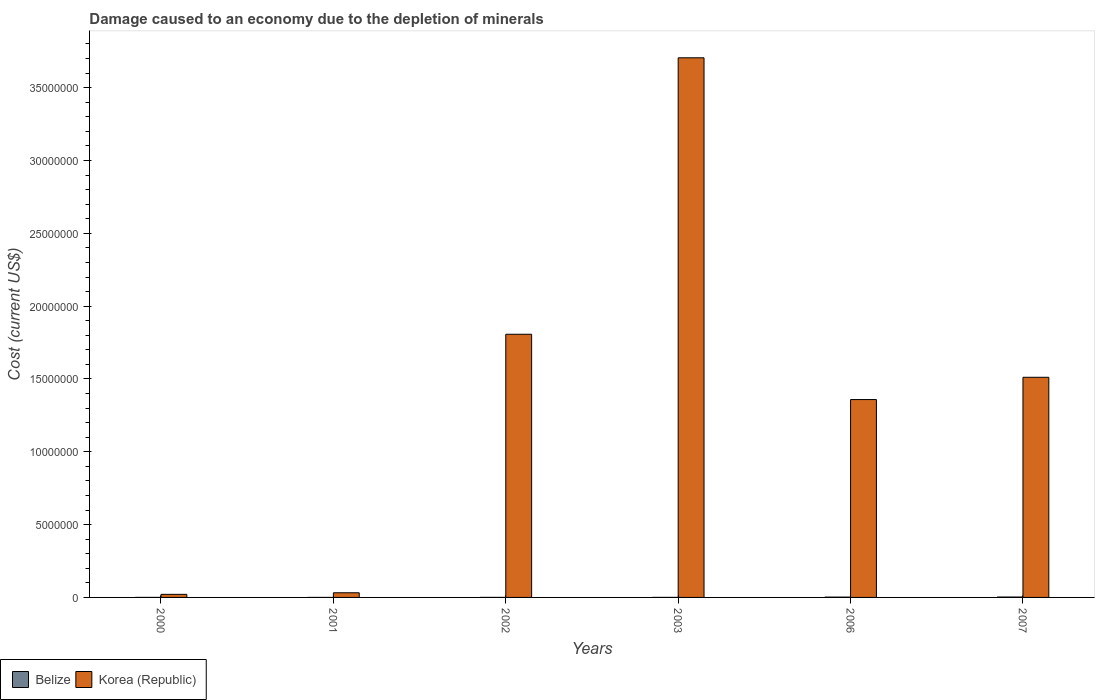How many groups of bars are there?
Make the answer very short. 6. Are the number of bars on each tick of the X-axis equal?
Your answer should be very brief. Yes. How many bars are there on the 3rd tick from the left?
Give a very brief answer. 2. What is the label of the 1st group of bars from the left?
Your answer should be compact. 2000. In how many cases, is the number of bars for a given year not equal to the number of legend labels?
Your answer should be compact. 0. What is the cost of damage caused due to the depletion of minerals in Korea (Republic) in 2002?
Provide a succinct answer. 1.81e+07. Across all years, what is the maximum cost of damage caused due to the depletion of minerals in Korea (Republic)?
Provide a short and direct response. 3.71e+07. Across all years, what is the minimum cost of damage caused due to the depletion of minerals in Belize?
Your response must be concise. 126.73. In which year was the cost of damage caused due to the depletion of minerals in Korea (Republic) maximum?
Offer a terse response. 2003. In which year was the cost of damage caused due to the depletion of minerals in Korea (Republic) minimum?
Your response must be concise. 2000. What is the total cost of damage caused due to the depletion of minerals in Korea (Republic) in the graph?
Provide a succinct answer. 8.44e+07. What is the difference between the cost of damage caused due to the depletion of minerals in Korea (Republic) in 2000 and that in 2002?
Keep it short and to the point. -1.79e+07. What is the difference between the cost of damage caused due to the depletion of minerals in Korea (Republic) in 2000 and the cost of damage caused due to the depletion of minerals in Belize in 2001?
Make the answer very short. 2.11e+05. What is the average cost of damage caused due to the depletion of minerals in Korea (Republic) per year?
Make the answer very short. 1.41e+07. In the year 2002, what is the difference between the cost of damage caused due to the depletion of minerals in Korea (Republic) and cost of damage caused due to the depletion of minerals in Belize?
Your answer should be compact. 1.81e+07. In how many years, is the cost of damage caused due to the depletion of minerals in Belize greater than 21000000 US$?
Your response must be concise. 0. What is the ratio of the cost of damage caused due to the depletion of minerals in Korea (Republic) in 2000 to that in 2001?
Offer a terse response. 0.66. What is the difference between the highest and the second highest cost of damage caused due to the depletion of minerals in Belize?
Your response must be concise. 5266.77. What is the difference between the highest and the lowest cost of damage caused due to the depletion of minerals in Belize?
Make the answer very short. 2.62e+04. In how many years, is the cost of damage caused due to the depletion of minerals in Belize greater than the average cost of damage caused due to the depletion of minerals in Belize taken over all years?
Provide a succinct answer. 2. What does the 1st bar from the left in 2001 represents?
Keep it short and to the point. Belize. What does the 2nd bar from the right in 2003 represents?
Your answer should be very brief. Belize. How many bars are there?
Make the answer very short. 12. Are all the bars in the graph horizontal?
Provide a short and direct response. No. What is the difference between two consecutive major ticks on the Y-axis?
Offer a very short reply. 5.00e+06. Are the values on the major ticks of Y-axis written in scientific E-notation?
Provide a short and direct response. No. Does the graph contain grids?
Offer a very short reply. No. Where does the legend appear in the graph?
Your answer should be very brief. Bottom left. How many legend labels are there?
Ensure brevity in your answer.  2. How are the legend labels stacked?
Give a very brief answer. Horizontal. What is the title of the graph?
Offer a terse response. Damage caused to an economy due to the depletion of minerals. Does "Guam" appear as one of the legend labels in the graph?
Your response must be concise. No. What is the label or title of the X-axis?
Your response must be concise. Years. What is the label or title of the Y-axis?
Offer a very short reply. Cost (current US$). What is the Cost (current US$) in Belize in 2000?
Offer a very short reply. 573.17. What is the Cost (current US$) in Korea (Republic) in 2000?
Provide a short and direct response. 2.11e+05. What is the Cost (current US$) of Belize in 2001?
Provide a short and direct response. 126.73. What is the Cost (current US$) of Korea (Republic) in 2001?
Give a very brief answer. 3.20e+05. What is the Cost (current US$) in Belize in 2002?
Your answer should be very brief. 1479.97. What is the Cost (current US$) of Korea (Republic) in 2002?
Ensure brevity in your answer.  1.81e+07. What is the Cost (current US$) of Belize in 2003?
Offer a terse response. 1960.29. What is the Cost (current US$) in Korea (Republic) in 2003?
Provide a short and direct response. 3.71e+07. What is the Cost (current US$) in Belize in 2006?
Give a very brief answer. 2.10e+04. What is the Cost (current US$) in Korea (Republic) in 2006?
Offer a terse response. 1.36e+07. What is the Cost (current US$) of Belize in 2007?
Keep it short and to the point. 2.63e+04. What is the Cost (current US$) in Korea (Republic) in 2007?
Offer a terse response. 1.51e+07. Across all years, what is the maximum Cost (current US$) in Belize?
Ensure brevity in your answer.  2.63e+04. Across all years, what is the maximum Cost (current US$) in Korea (Republic)?
Your response must be concise. 3.71e+07. Across all years, what is the minimum Cost (current US$) in Belize?
Your answer should be very brief. 126.73. Across all years, what is the minimum Cost (current US$) in Korea (Republic)?
Offer a terse response. 2.11e+05. What is the total Cost (current US$) in Belize in the graph?
Your response must be concise. 5.15e+04. What is the total Cost (current US$) of Korea (Republic) in the graph?
Keep it short and to the point. 8.44e+07. What is the difference between the Cost (current US$) of Belize in 2000 and that in 2001?
Provide a succinct answer. 446.44. What is the difference between the Cost (current US$) of Korea (Republic) in 2000 and that in 2001?
Your answer should be very brief. -1.09e+05. What is the difference between the Cost (current US$) in Belize in 2000 and that in 2002?
Your answer should be very brief. -906.8. What is the difference between the Cost (current US$) in Korea (Republic) in 2000 and that in 2002?
Your answer should be compact. -1.79e+07. What is the difference between the Cost (current US$) in Belize in 2000 and that in 2003?
Make the answer very short. -1387.12. What is the difference between the Cost (current US$) of Korea (Republic) in 2000 and that in 2003?
Your response must be concise. -3.68e+07. What is the difference between the Cost (current US$) of Belize in 2000 and that in 2006?
Offer a terse response. -2.05e+04. What is the difference between the Cost (current US$) in Korea (Republic) in 2000 and that in 2006?
Offer a terse response. -1.34e+07. What is the difference between the Cost (current US$) of Belize in 2000 and that in 2007?
Keep it short and to the point. -2.57e+04. What is the difference between the Cost (current US$) of Korea (Republic) in 2000 and that in 2007?
Provide a succinct answer. -1.49e+07. What is the difference between the Cost (current US$) in Belize in 2001 and that in 2002?
Your response must be concise. -1353.24. What is the difference between the Cost (current US$) in Korea (Republic) in 2001 and that in 2002?
Keep it short and to the point. -1.78e+07. What is the difference between the Cost (current US$) in Belize in 2001 and that in 2003?
Make the answer very short. -1833.56. What is the difference between the Cost (current US$) in Korea (Republic) in 2001 and that in 2003?
Provide a succinct answer. -3.67e+07. What is the difference between the Cost (current US$) in Belize in 2001 and that in 2006?
Provide a short and direct response. -2.09e+04. What is the difference between the Cost (current US$) in Korea (Republic) in 2001 and that in 2006?
Your response must be concise. -1.33e+07. What is the difference between the Cost (current US$) in Belize in 2001 and that in 2007?
Provide a short and direct response. -2.62e+04. What is the difference between the Cost (current US$) of Korea (Republic) in 2001 and that in 2007?
Your answer should be very brief. -1.48e+07. What is the difference between the Cost (current US$) in Belize in 2002 and that in 2003?
Make the answer very short. -480.32. What is the difference between the Cost (current US$) in Korea (Republic) in 2002 and that in 2003?
Your answer should be compact. -1.90e+07. What is the difference between the Cost (current US$) of Belize in 2002 and that in 2006?
Give a very brief answer. -1.96e+04. What is the difference between the Cost (current US$) of Korea (Republic) in 2002 and that in 2006?
Your answer should be very brief. 4.48e+06. What is the difference between the Cost (current US$) of Belize in 2002 and that in 2007?
Ensure brevity in your answer.  -2.48e+04. What is the difference between the Cost (current US$) in Korea (Republic) in 2002 and that in 2007?
Keep it short and to the point. 2.95e+06. What is the difference between the Cost (current US$) of Belize in 2003 and that in 2006?
Ensure brevity in your answer.  -1.91e+04. What is the difference between the Cost (current US$) in Korea (Republic) in 2003 and that in 2006?
Ensure brevity in your answer.  2.35e+07. What is the difference between the Cost (current US$) in Belize in 2003 and that in 2007?
Give a very brief answer. -2.43e+04. What is the difference between the Cost (current US$) of Korea (Republic) in 2003 and that in 2007?
Offer a terse response. 2.19e+07. What is the difference between the Cost (current US$) of Belize in 2006 and that in 2007?
Ensure brevity in your answer.  -5266.77. What is the difference between the Cost (current US$) of Korea (Republic) in 2006 and that in 2007?
Offer a very short reply. -1.53e+06. What is the difference between the Cost (current US$) in Belize in 2000 and the Cost (current US$) in Korea (Republic) in 2001?
Offer a very short reply. -3.19e+05. What is the difference between the Cost (current US$) of Belize in 2000 and the Cost (current US$) of Korea (Republic) in 2002?
Your answer should be compact. -1.81e+07. What is the difference between the Cost (current US$) in Belize in 2000 and the Cost (current US$) in Korea (Republic) in 2003?
Your answer should be very brief. -3.71e+07. What is the difference between the Cost (current US$) in Belize in 2000 and the Cost (current US$) in Korea (Republic) in 2006?
Your answer should be very brief. -1.36e+07. What is the difference between the Cost (current US$) in Belize in 2000 and the Cost (current US$) in Korea (Republic) in 2007?
Offer a terse response. -1.51e+07. What is the difference between the Cost (current US$) in Belize in 2001 and the Cost (current US$) in Korea (Republic) in 2002?
Provide a succinct answer. -1.81e+07. What is the difference between the Cost (current US$) of Belize in 2001 and the Cost (current US$) of Korea (Republic) in 2003?
Ensure brevity in your answer.  -3.71e+07. What is the difference between the Cost (current US$) in Belize in 2001 and the Cost (current US$) in Korea (Republic) in 2006?
Give a very brief answer. -1.36e+07. What is the difference between the Cost (current US$) of Belize in 2001 and the Cost (current US$) of Korea (Republic) in 2007?
Ensure brevity in your answer.  -1.51e+07. What is the difference between the Cost (current US$) of Belize in 2002 and the Cost (current US$) of Korea (Republic) in 2003?
Your response must be concise. -3.71e+07. What is the difference between the Cost (current US$) of Belize in 2002 and the Cost (current US$) of Korea (Republic) in 2006?
Keep it short and to the point. -1.36e+07. What is the difference between the Cost (current US$) of Belize in 2002 and the Cost (current US$) of Korea (Republic) in 2007?
Give a very brief answer. -1.51e+07. What is the difference between the Cost (current US$) in Belize in 2003 and the Cost (current US$) in Korea (Republic) in 2006?
Keep it short and to the point. -1.36e+07. What is the difference between the Cost (current US$) of Belize in 2003 and the Cost (current US$) of Korea (Republic) in 2007?
Offer a terse response. -1.51e+07. What is the difference between the Cost (current US$) in Belize in 2006 and the Cost (current US$) in Korea (Republic) in 2007?
Ensure brevity in your answer.  -1.51e+07. What is the average Cost (current US$) of Belize per year?
Offer a terse response. 8580.35. What is the average Cost (current US$) of Korea (Republic) per year?
Your response must be concise. 1.41e+07. In the year 2000, what is the difference between the Cost (current US$) of Belize and Cost (current US$) of Korea (Republic)?
Your answer should be very brief. -2.10e+05. In the year 2001, what is the difference between the Cost (current US$) in Belize and Cost (current US$) in Korea (Republic)?
Offer a terse response. -3.20e+05. In the year 2002, what is the difference between the Cost (current US$) of Belize and Cost (current US$) of Korea (Republic)?
Offer a terse response. -1.81e+07. In the year 2003, what is the difference between the Cost (current US$) of Belize and Cost (current US$) of Korea (Republic)?
Ensure brevity in your answer.  -3.70e+07. In the year 2006, what is the difference between the Cost (current US$) in Belize and Cost (current US$) in Korea (Republic)?
Your response must be concise. -1.36e+07. In the year 2007, what is the difference between the Cost (current US$) in Belize and Cost (current US$) in Korea (Republic)?
Your answer should be compact. -1.51e+07. What is the ratio of the Cost (current US$) of Belize in 2000 to that in 2001?
Make the answer very short. 4.52. What is the ratio of the Cost (current US$) of Korea (Republic) in 2000 to that in 2001?
Keep it short and to the point. 0.66. What is the ratio of the Cost (current US$) in Belize in 2000 to that in 2002?
Provide a succinct answer. 0.39. What is the ratio of the Cost (current US$) of Korea (Republic) in 2000 to that in 2002?
Your response must be concise. 0.01. What is the ratio of the Cost (current US$) of Belize in 2000 to that in 2003?
Provide a short and direct response. 0.29. What is the ratio of the Cost (current US$) of Korea (Republic) in 2000 to that in 2003?
Provide a succinct answer. 0.01. What is the ratio of the Cost (current US$) in Belize in 2000 to that in 2006?
Provide a succinct answer. 0.03. What is the ratio of the Cost (current US$) in Korea (Republic) in 2000 to that in 2006?
Keep it short and to the point. 0.02. What is the ratio of the Cost (current US$) in Belize in 2000 to that in 2007?
Your answer should be compact. 0.02. What is the ratio of the Cost (current US$) of Korea (Republic) in 2000 to that in 2007?
Offer a terse response. 0.01. What is the ratio of the Cost (current US$) of Belize in 2001 to that in 2002?
Make the answer very short. 0.09. What is the ratio of the Cost (current US$) of Korea (Republic) in 2001 to that in 2002?
Provide a short and direct response. 0.02. What is the ratio of the Cost (current US$) in Belize in 2001 to that in 2003?
Your answer should be compact. 0.06. What is the ratio of the Cost (current US$) of Korea (Republic) in 2001 to that in 2003?
Provide a succinct answer. 0.01. What is the ratio of the Cost (current US$) in Belize in 2001 to that in 2006?
Ensure brevity in your answer.  0.01. What is the ratio of the Cost (current US$) of Korea (Republic) in 2001 to that in 2006?
Offer a terse response. 0.02. What is the ratio of the Cost (current US$) in Belize in 2001 to that in 2007?
Provide a short and direct response. 0. What is the ratio of the Cost (current US$) in Korea (Republic) in 2001 to that in 2007?
Offer a very short reply. 0.02. What is the ratio of the Cost (current US$) of Belize in 2002 to that in 2003?
Your response must be concise. 0.76. What is the ratio of the Cost (current US$) of Korea (Republic) in 2002 to that in 2003?
Ensure brevity in your answer.  0.49. What is the ratio of the Cost (current US$) of Belize in 2002 to that in 2006?
Ensure brevity in your answer.  0.07. What is the ratio of the Cost (current US$) of Korea (Republic) in 2002 to that in 2006?
Provide a succinct answer. 1.33. What is the ratio of the Cost (current US$) of Belize in 2002 to that in 2007?
Your answer should be compact. 0.06. What is the ratio of the Cost (current US$) in Korea (Republic) in 2002 to that in 2007?
Your answer should be compact. 1.2. What is the ratio of the Cost (current US$) in Belize in 2003 to that in 2006?
Ensure brevity in your answer.  0.09. What is the ratio of the Cost (current US$) in Korea (Republic) in 2003 to that in 2006?
Provide a short and direct response. 2.73. What is the ratio of the Cost (current US$) of Belize in 2003 to that in 2007?
Your answer should be compact. 0.07. What is the ratio of the Cost (current US$) of Korea (Republic) in 2003 to that in 2007?
Keep it short and to the point. 2.45. What is the ratio of the Cost (current US$) of Belize in 2006 to that in 2007?
Your answer should be compact. 0.8. What is the ratio of the Cost (current US$) of Korea (Republic) in 2006 to that in 2007?
Offer a very short reply. 0.9. What is the difference between the highest and the second highest Cost (current US$) in Belize?
Provide a succinct answer. 5266.77. What is the difference between the highest and the second highest Cost (current US$) in Korea (Republic)?
Provide a short and direct response. 1.90e+07. What is the difference between the highest and the lowest Cost (current US$) in Belize?
Offer a very short reply. 2.62e+04. What is the difference between the highest and the lowest Cost (current US$) in Korea (Republic)?
Provide a succinct answer. 3.68e+07. 